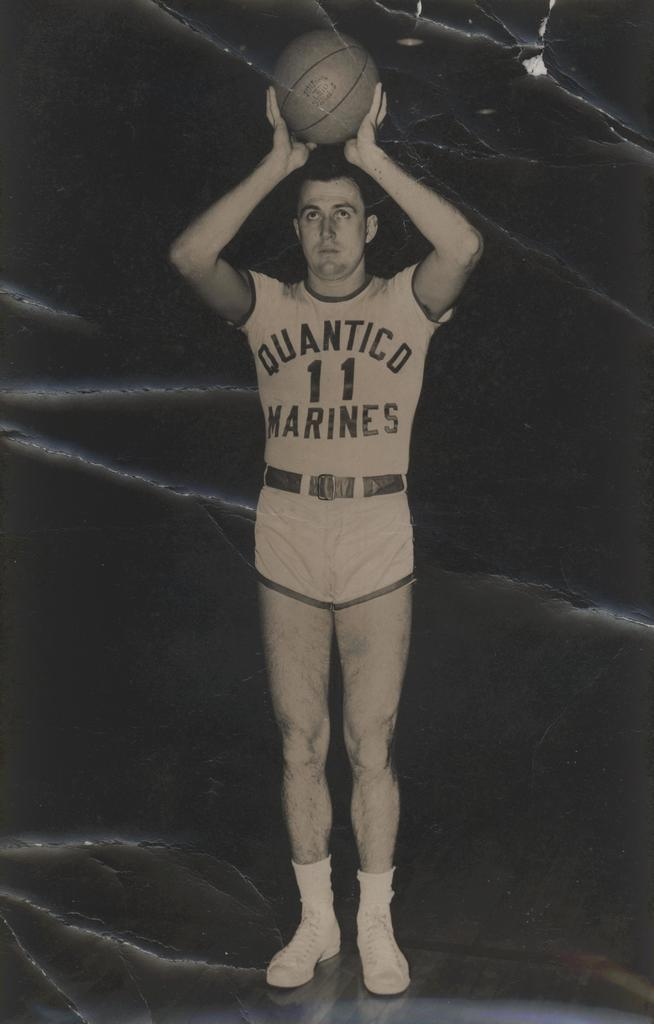<image>
Relay a brief, clear account of the picture shown. a man playing basketball while wearing a quantico marines jersey number 11 